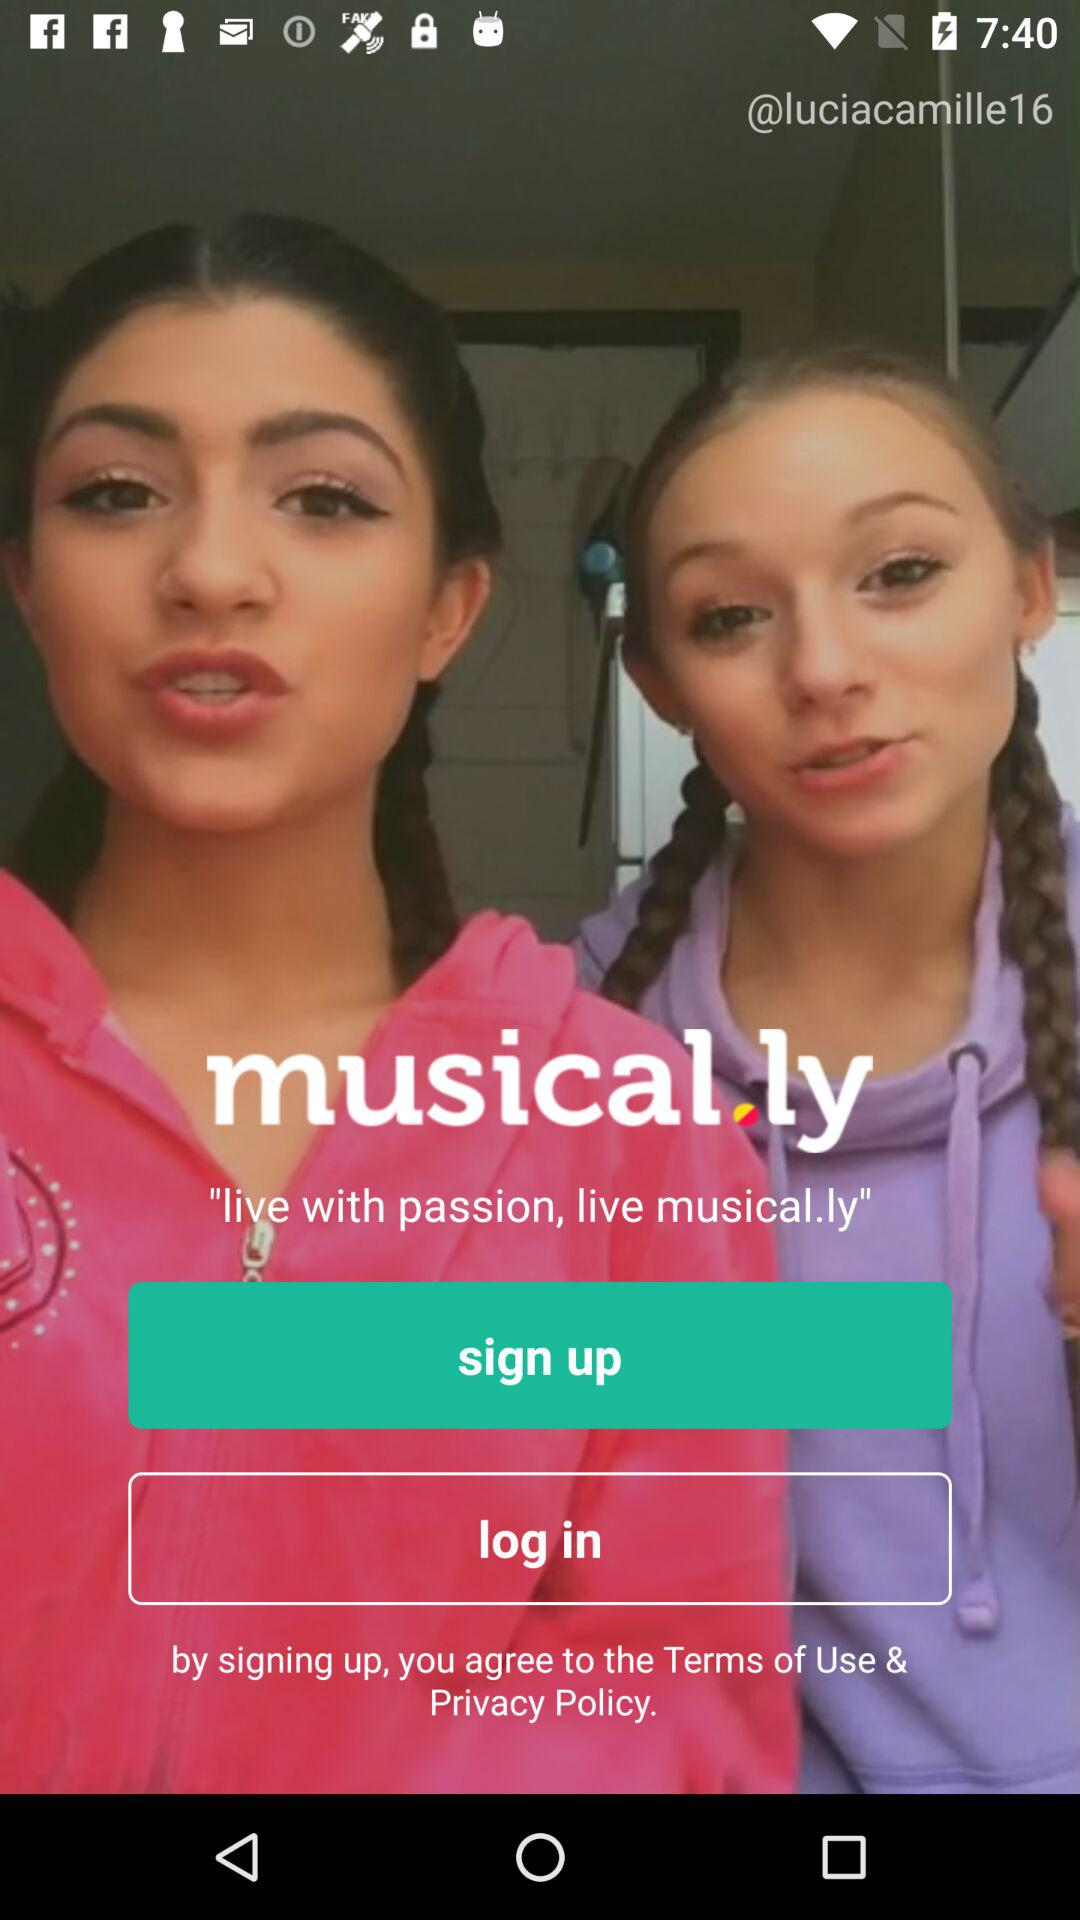What is the name of the application? The name of the application is "musical.ly". 